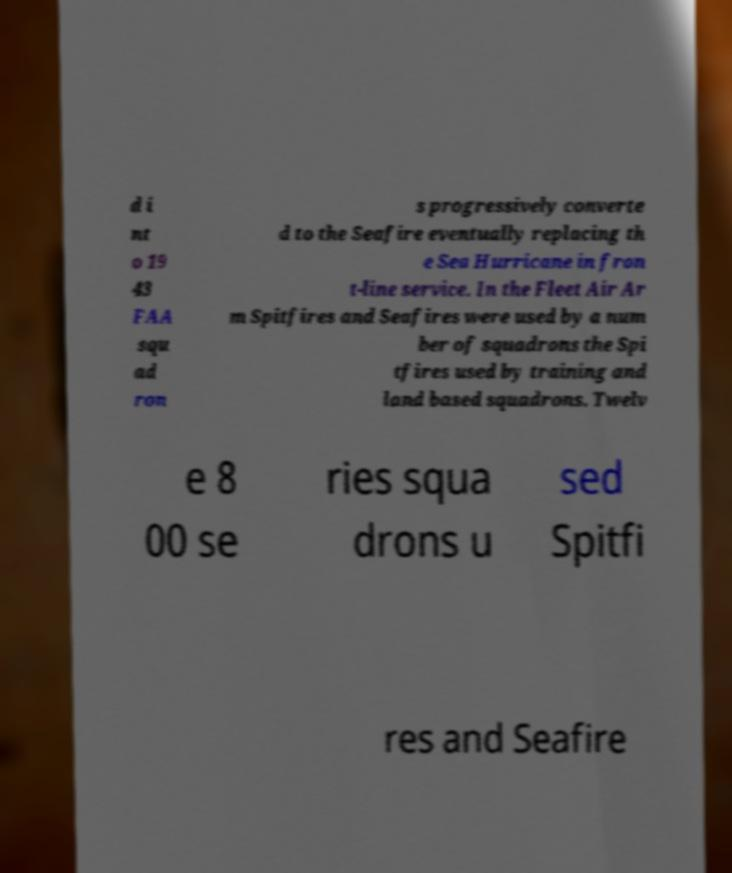Please read and relay the text visible in this image. What does it say? d i nt o 19 43 FAA squ ad ron s progressively converte d to the Seafire eventually replacing th e Sea Hurricane in fron t-line service. In the Fleet Air Ar m Spitfires and Seafires were used by a num ber of squadrons the Spi tfires used by training and land based squadrons. Twelv e 8 00 se ries squa drons u sed Spitfi res and Seafire 